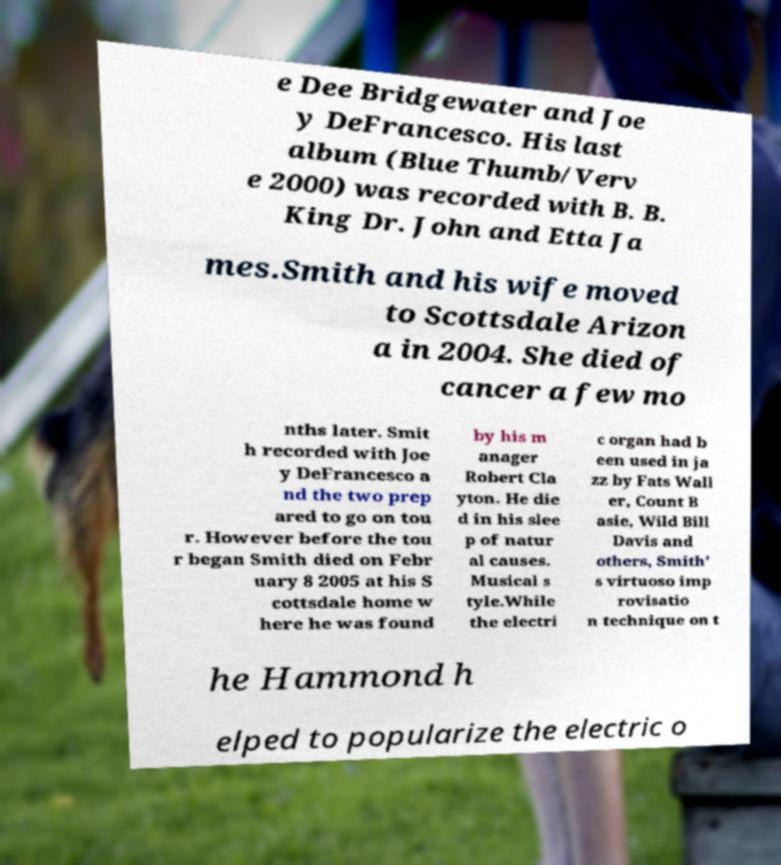There's text embedded in this image that I need extracted. Can you transcribe it verbatim? e Dee Bridgewater and Joe y DeFrancesco. His last album (Blue Thumb/Verv e 2000) was recorded with B. B. King Dr. John and Etta Ja mes.Smith and his wife moved to Scottsdale Arizon a in 2004. She died of cancer a few mo nths later. Smit h recorded with Joe y DeFrancesco a nd the two prep ared to go on tou r. However before the tou r began Smith died on Febr uary 8 2005 at his S cottsdale home w here he was found by his m anager Robert Cla yton. He die d in his slee p of natur al causes. Musical s tyle.While the electri c organ had b een used in ja zz by Fats Wall er, Count B asie, Wild Bill Davis and others, Smith' s virtuoso imp rovisatio n technique on t he Hammond h elped to popularize the electric o 